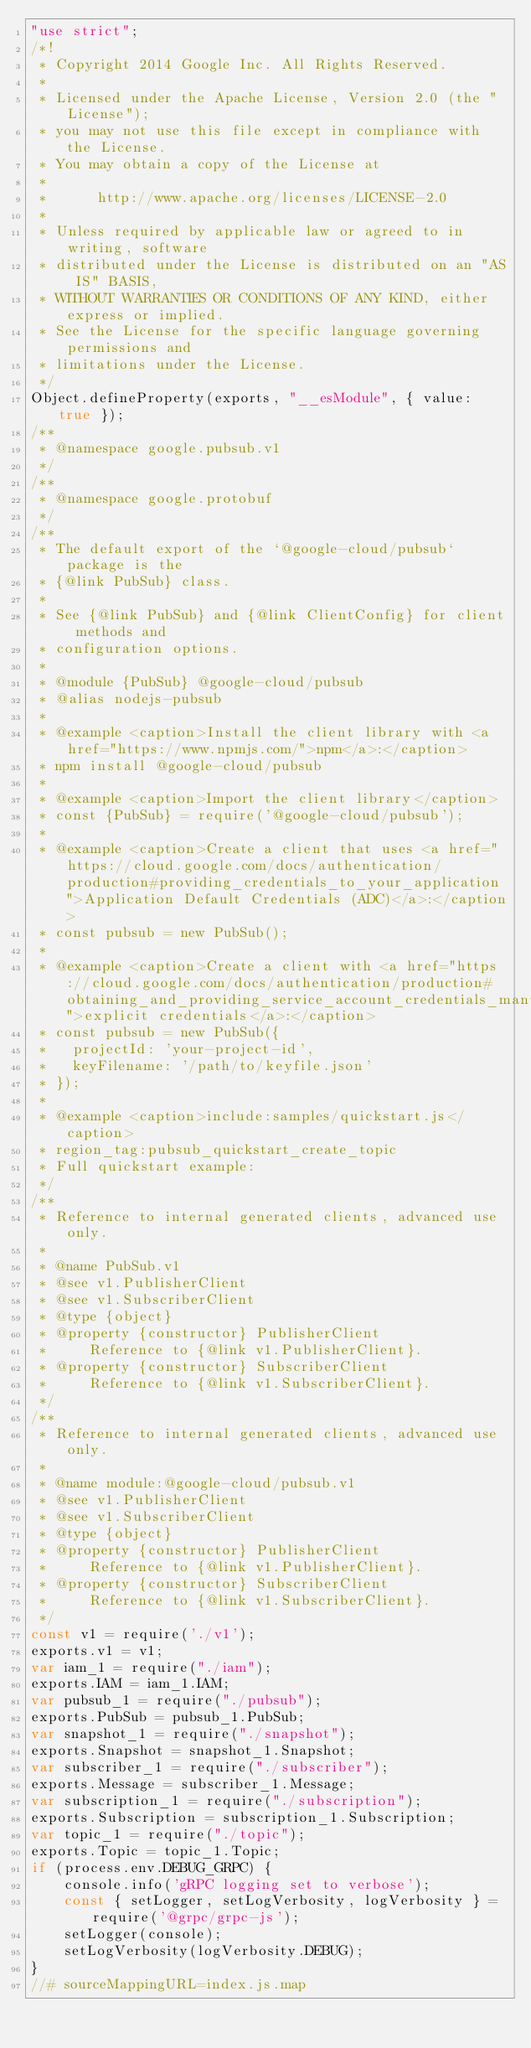<code> <loc_0><loc_0><loc_500><loc_500><_JavaScript_>"use strict";
/*!
 * Copyright 2014 Google Inc. All Rights Reserved.
 *
 * Licensed under the Apache License, Version 2.0 (the "License");
 * you may not use this file except in compliance with the License.
 * You may obtain a copy of the License at
 *
 *      http://www.apache.org/licenses/LICENSE-2.0
 *
 * Unless required by applicable law or agreed to in writing, software
 * distributed under the License is distributed on an "AS IS" BASIS,
 * WITHOUT WARRANTIES OR CONDITIONS OF ANY KIND, either express or implied.
 * See the License for the specific language governing permissions and
 * limitations under the License.
 */
Object.defineProperty(exports, "__esModule", { value: true });
/**
 * @namespace google.pubsub.v1
 */
/**
 * @namespace google.protobuf
 */
/**
 * The default export of the `@google-cloud/pubsub` package is the
 * {@link PubSub} class.
 *
 * See {@link PubSub} and {@link ClientConfig} for client methods and
 * configuration options.
 *
 * @module {PubSub} @google-cloud/pubsub
 * @alias nodejs-pubsub
 *
 * @example <caption>Install the client library with <a href="https://www.npmjs.com/">npm</a>:</caption>
 * npm install @google-cloud/pubsub
 *
 * @example <caption>Import the client library</caption>
 * const {PubSub} = require('@google-cloud/pubsub');
 *
 * @example <caption>Create a client that uses <a href="https://cloud.google.com/docs/authentication/production#providing_credentials_to_your_application">Application Default Credentials (ADC)</a>:</caption>
 * const pubsub = new PubSub();
 *
 * @example <caption>Create a client with <a href="https://cloud.google.com/docs/authentication/production#obtaining_and_providing_service_account_credentials_manually">explicit credentials</a>:</caption>
 * const pubsub = new PubSub({
 *   projectId: 'your-project-id',
 *   keyFilename: '/path/to/keyfile.json'
 * });
 *
 * @example <caption>include:samples/quickstart.js</caption>
 * region_tag:pubsub_quickstart_create_topic
 * Full quickstart example:
 */
/**
 * Reference to internal generated clients, advanced use only.
 *
 * @name PubSub.v1
 * @see v1.PublisherClient
 * @see v1.SubscriberClient
 * @type {object}
 * @property {constructor} PublisherClient
 *     Reference to {@link v1.PublisherClient}.
 * @property {constructor} SubscriberClient
 *     Reference to {@link v1.SubscriberClient}.
 */
/**
 * Reference to internal generated clients, advanced use only.
 *
 * @name module:@google-cloud/pubsub.v1
 * @see v1.PublisherClient
 * @see v1.SubscriberClient
 * @type {object}
 * @property {constructor} PublisherClient
 *     Reference to {@link v1.PublisherClient}.
 * @property {constructor} SubscriberClient
 *     Reference to {@link v1.SubscriberClient}.
 */
const v1 = require('./v1');
exports.v1 = v1;
var iam_1 = require("./iam");
exports.IAM = iam_1.IAM;
var pubsub_1 = require("./pubsub");
exports.PubSub = pubsub_1.PubSub;
var snapshot_1 = require("./snapshot");
exports.Snapshot = snapshot_1.Snapshot;
var subscriber_1 = require("./subscriber");
exports.Message = subscriber_1.Message;
var subscription_1 = require("./subscription");
exports.Subscription = subscription_1.Subscription;
var topic_1 = require("./topic");
exports.Topic = topic_1.Topic;
if (process.env.DEBUG_GRPC) {
    console.info('gRPC logging set to verbose');
    const { setLogger, setLogVerbosity, logVerbosity } = require('@grpc/grpc-js');
    setLogger(console);
    setLogVerbosity(logVerbosity.DEBUG);
}
//# sourceMappingURL=index.js.map</code> 